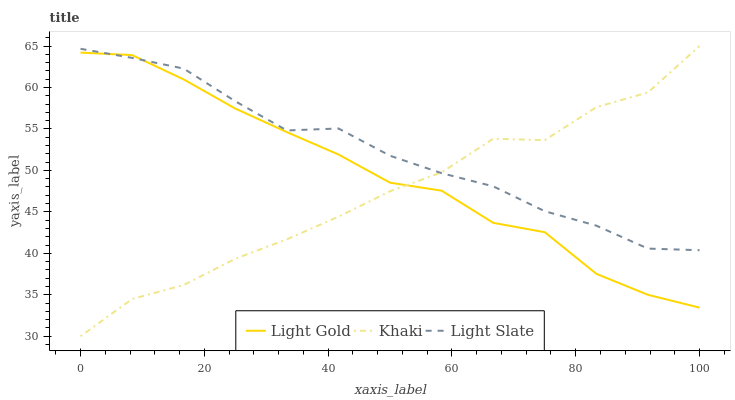Does Khaki have the minimum area under the curve?
Answer yes or no. Yes. Does Light Slate have the maximum area under the curve?
Answer yes or no. Yes. Does Light Gold have the minimum area under the curve?
Answer yes or no. No. Does Light Gold have the maximum area under the curve?
Answer yes or no. No. Is Light Slate the smoothest?
Answer yes or no. Yes. Is Khaki the roughest?
Answer yes or no. Yes. Is Light Gold the smoothest?
Answer yes or no. No. Is Light Gold the roughest?
Answer yes or no. No. Does Khaki have the lowest value?
Answer yes or no. Yes. Does Light Gold have the lowest value?
Answer yes or no. No. Does Khaki have the highest value?
Answer yes or no. Yes. Does Light Gold have the highest value?
Answer yes or no. No. Does Light Gold intersect Khaki?
Answer yes or no. Yes. Is Light Gold less than Khaki?
Answer yes or no. No. Is Light Gold greater than Khaki?
Answer yes or no. No. 